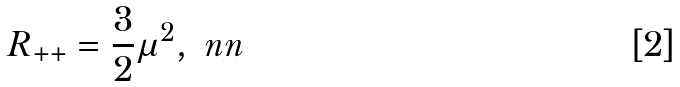Convert formula to latex. <formula><loc_0><loc_0><loc_500><loc_500>R _ { + + } = \frac { 3 } { 2 } \mu ^ { 2 } , \ n n</formula> 